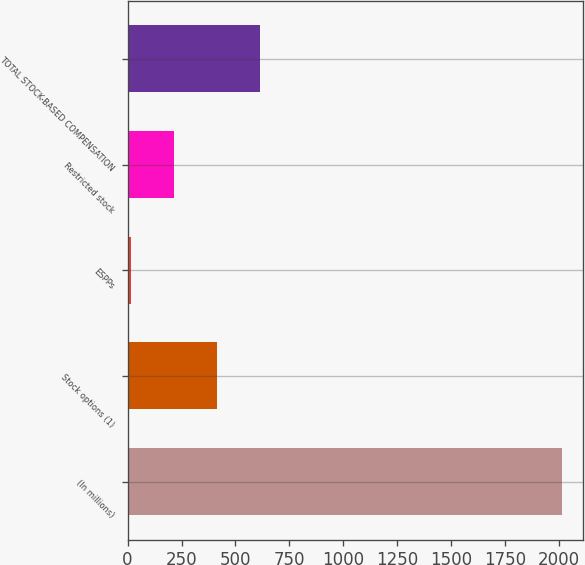Convert chart. <chart><loc_0><loc_0><loc_500><loc_500><bar_chart><fcel>(In millions)<fcel>Stock options (1)<fcel>ESPPs<fcel>Restricted stock<fcel>TOTAL STOCK-BASED COMPENSATION<nl><fcel>2012<fcel>415.2<fcel>16<fcel>215.6<fcel>614.8<nl></chart> 